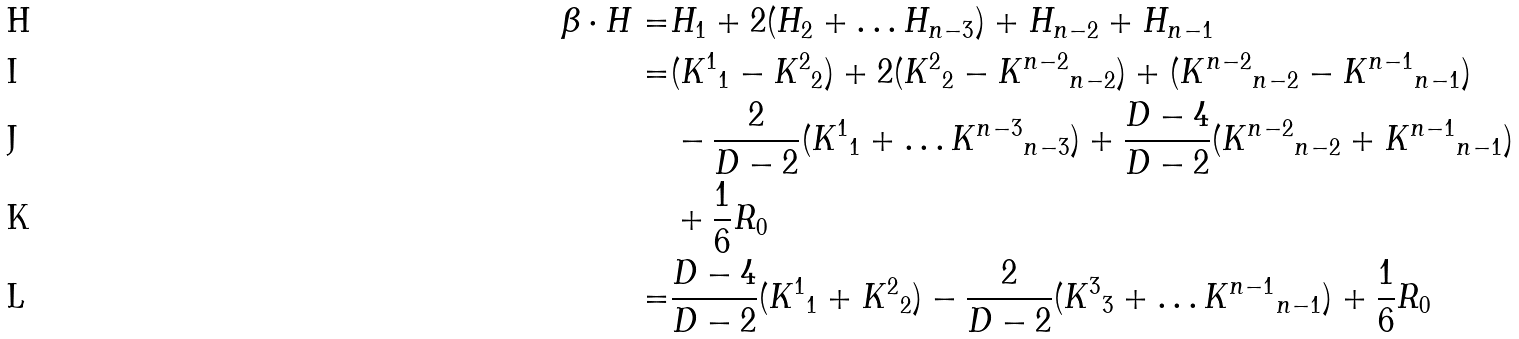<formula> <loc_0><loc_0><loc_500><loc_500>\beta \cdot H = & H _ { 1 } + 2 ( H _ { 2 } + \dots H _ { n - 3 } ) + H _ { n - 2 } + H _ { n - 1 } \\ = & ( { K ^ { 1 } } _ { 1 } - { K ^ { 2 } } _ { 2 } ) + 2 ( { K ^ { 2 } } _ { 2 } - { K ^ { n - 2 } } _ { n - 2 } ) + ( { K ^ { n - 2 } } _ { n - 2 } - { K ^ { n - 1 } } _ { n - 1 } ) \\ & - \frac { 2 } { D - 2 } ( { K ^ { 1 } } _ { 1 } + \dots { K ^ { n - 3 } } _ { n - 3 } ) + \frac { D - 4 } { D - 2 } ( { K ^ { n - 2 } } _ { n - 2 } + { K ^ { n - 1 } } _ { n - 1 } ) \\ & + { \frac { 1 } { 6 } } R _ { 0 } \\ = & \frac { D - 4 } { D - 2 } ( { K ^ { 1 } } _ { 1 } + { K ^ { 2 } } _ { 2 } ) - \frac { 2 } { D - 2 } ( { K ^ { 3 } } _ { 3 } + \dots { K ^ { n - 1 } } _ { n - 1 } ) + { \frac { 1 } { 6 } } R _ { 0 }</formula> 